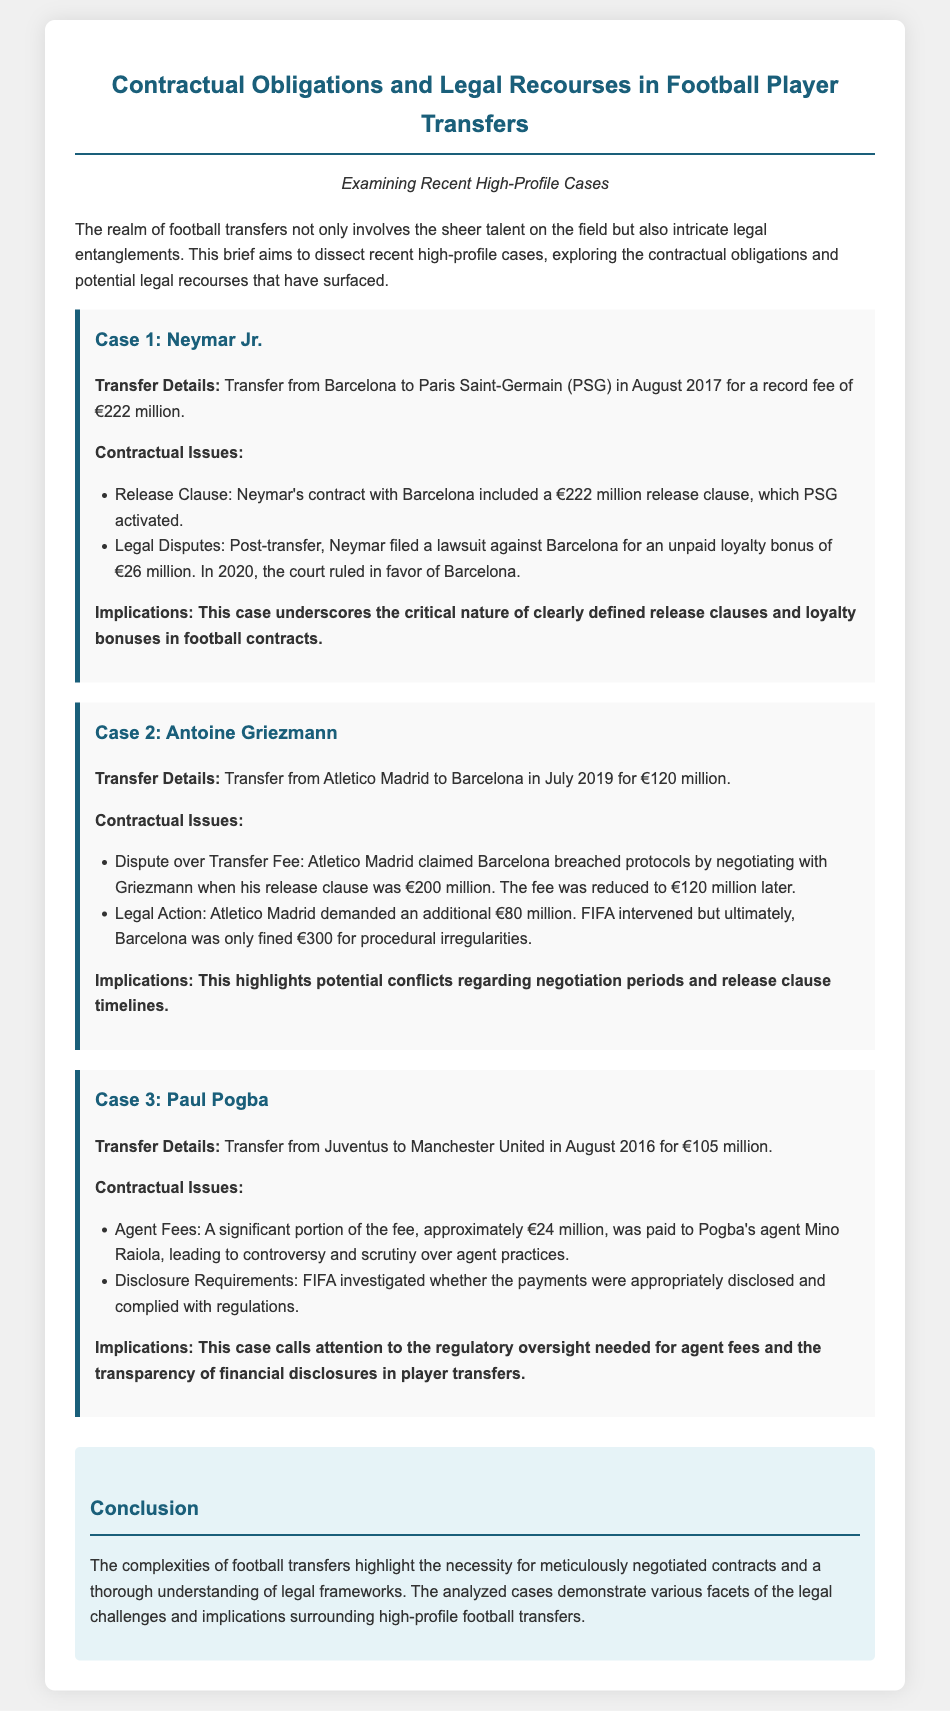What was the transfer fee for Neymar Jr.? The transfer fee for Neymar Jr. is specified as €222 million in the document.
Answer: €222 million What was the loyalty bonus amount Neymar filed a lawsuit for? The document states that Neymar filed a lawsuit for an unpaid loyalty bonus of €26 million.
Answer: €26 million Which club did Paul Pogba transfer from? The document specifies that Paul Pogba transferred from Juventus.
Answer: Juventus What fine did Barcelona receive in the Griezmann case? The document indicates that Barcelona was fined €300 for procedural irregularities.
Answer: €300 What was the initial release clause for Antoine Griezmann when Barcelona negotiated with him? The initial release clause for Antoine Griezmann was €200 million when negotiations occurred, as detailed in the document.
Answer: €200 million What was a significant concern in the Pogba transfer related to the fees? The document mentions scrutiny over agent practices concerning significant fees paid to Pogba's agent.
Answer: Agent fees What legal entity intervened in the Griezmann transfer dispute? The document specifies that FIFA intervened in the transfer dispute involving Antoine Griezmann.
Answer: FIFA What key aspect did the Neymar case highlight regarding football contracts? The case underscores the critical nature of clearly defined release clauses and loyalty bonuses in football contracts.
Answer: Release clauses What is the main focus of the legal brief? The main focus of the legal brief is to examine contractual obligations and legal recourses in football player transfers.
Answer: Contractual obligations and legal recourses 